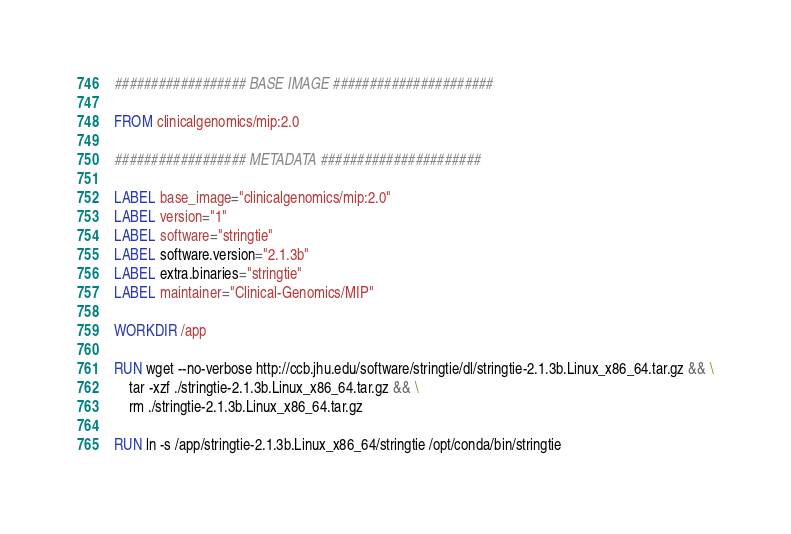Convert code to text. <code><loc_0><loc_0><loc_500><loc_500><_Dockerfile_>################## BASE IMAGE ######################

FROM clinicalgenomics/mip:2.0

################## METADATA ######################

LABEL base_image="clinicalgenomics/mip:2.0"
LABEL version="1"
LABEL software="stringtie"
LABEL software.version="2.1.3b"
LABEL extra.binaries="stringtie"
LABEL maintainer="Clinical-Genomics/MIP"

WORKDIR /app

RUN wget --no-verbose http://ccb.jhu.edu/software/stringtie/dl/stringtie-2.1.3b.Linux_x86_64.tar.gz && \
    tar -xzf ./stringtie-2.1.3b.Linux_x86_64.tar.gz && \
    rm ./stringtie-2.1.3b.Linux_x86_64.tar.gz

RUN ln -s /app/stringtie-2.1.3b.Linux_x86_64/stringtie /opt/conda/bin/stringtie
</code> 